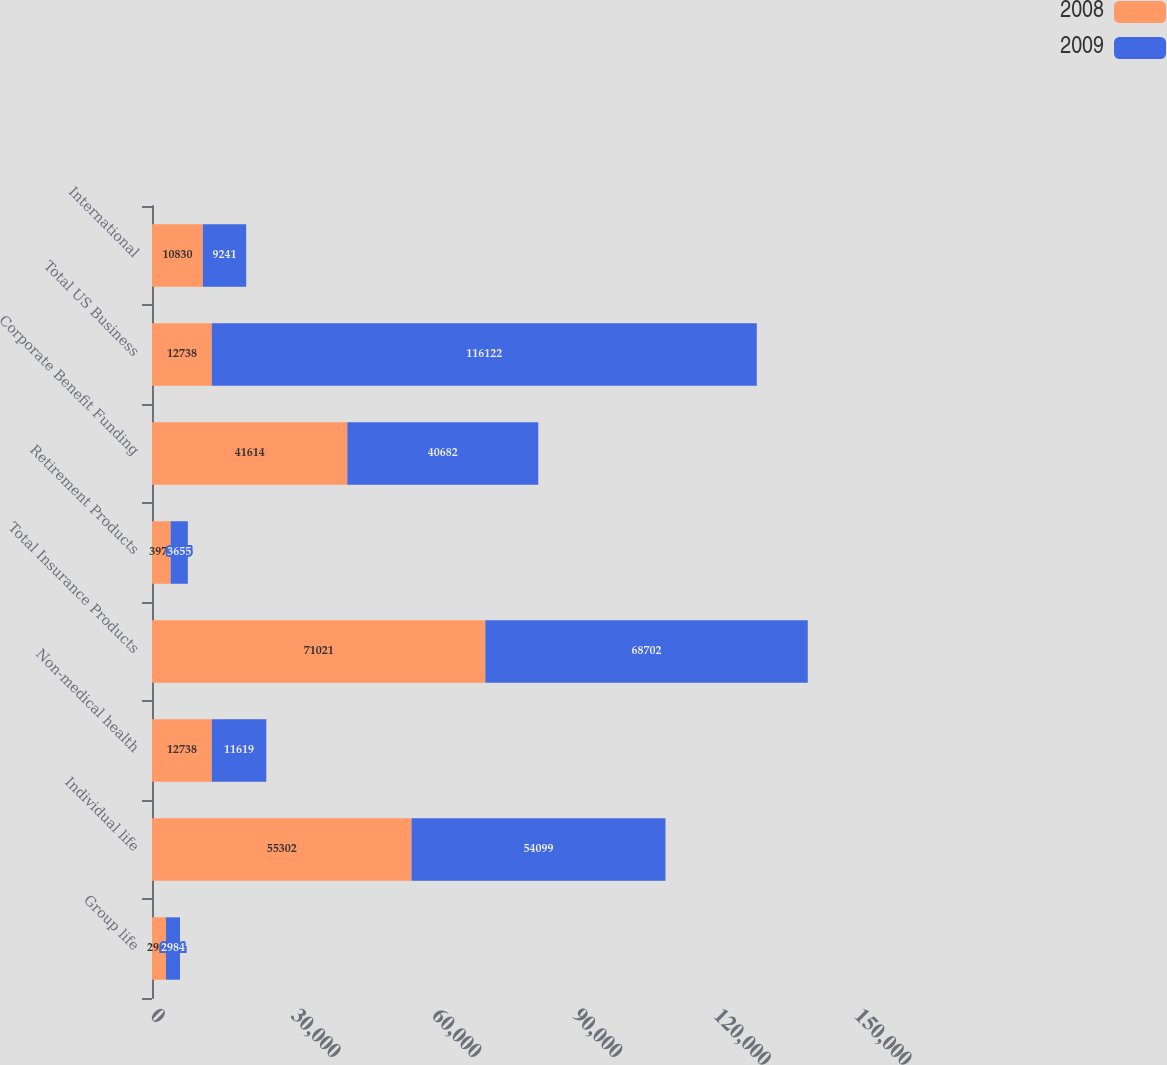Convert chart to OTSL. <chart><loc_0><loc_0><loc_500><loc_500><stacked_bar_chart><ecel><fcel>Group life<fcel>Individual life<fcel>Non-medical health<fcel>Total Insurance Products<fcel>Retirement Products<fcel>Corporate Benefit Funding<fcel>Total US Business<fcel>International<nl><fcel>2008<fcel>2981<fcel>55302<fcel>12738<fcel>71021<fcel>3978<fcel>41614<fcel>12738<fcel>10830<nl><fcel>2009<fcel>2984<fcel>54099<fcel>11619<fcel>68702<fcel>3655<fcel>40682<fcel>116122<fcel>9241<nl></chart> 